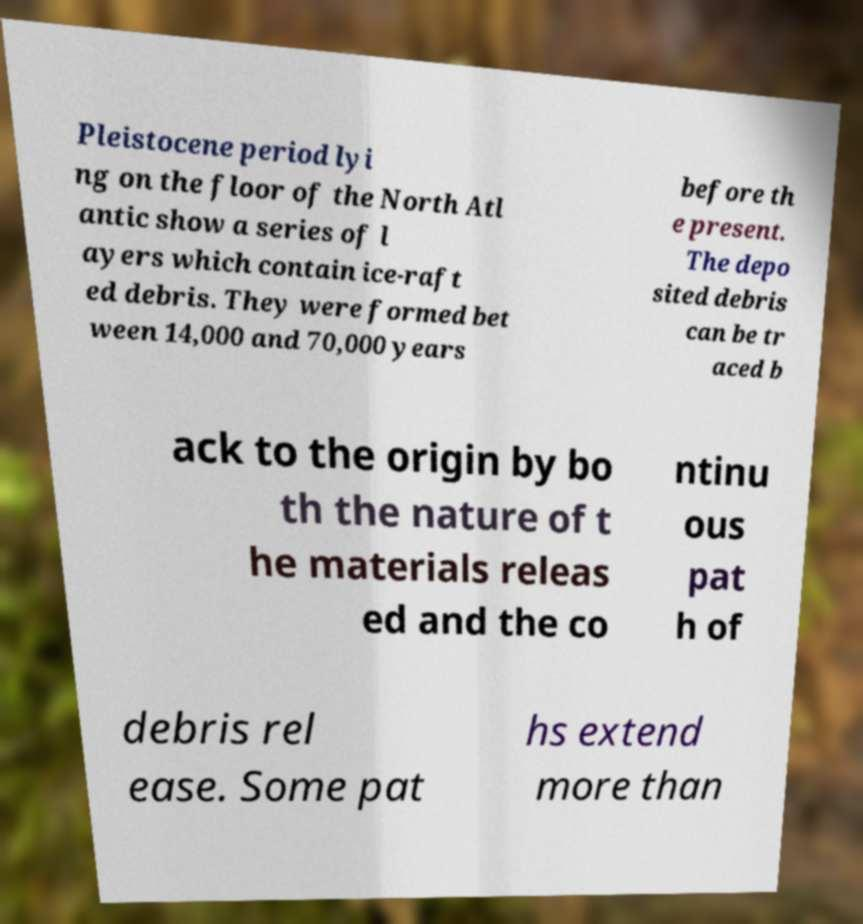Please identify and transcribe the text found in this image. Pleistocene period lyi ng on the floor of the North Atl antic show a series of l ayers which contain ice-raft ed debris. They were formed bet ween 14,000 and 70,000 years before th e present. The depo sited debris can be tr aced b ack to the origin by bo th the nature of t he materials releas ed and the co ntinu ous pat h of debris rel ease. Some pat hs extend more than 